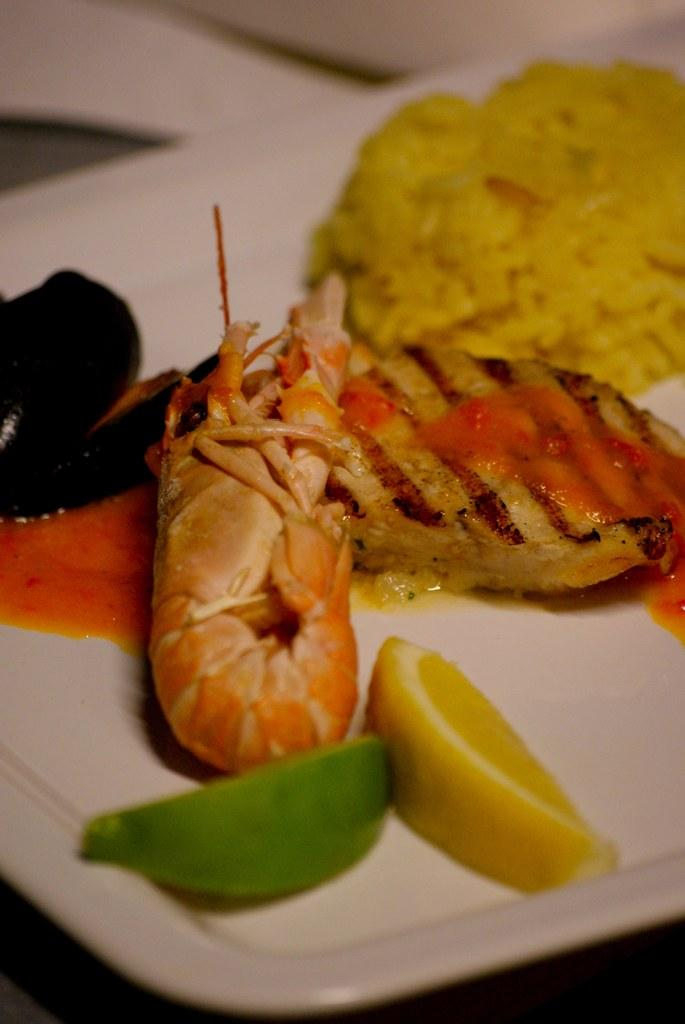What is on the plate that is visible in the image? The plate contains fruits. Are there any other food items on the plate? The plate may contain rice and meat items. Where might the image have been taken? The image is likely taken in a room. What scent can be detected from the plate in the image? There is no information about the scent of the food in the image, so it cannot be determined. 